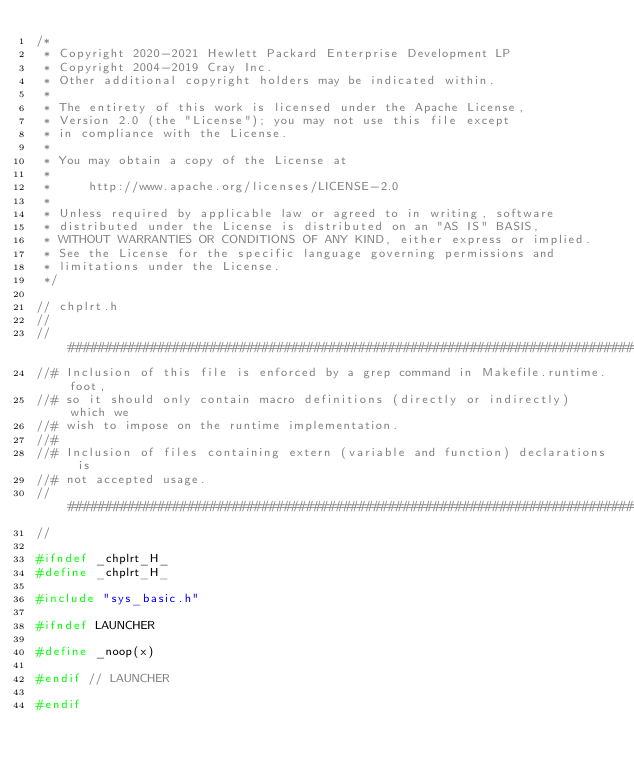<code> <loc_0><loc_0><loc_500><loc_500><_C_>/*
 * Copyright 2020-2021 Hewlett Packard Enterprise Development LP
 * Copyright 2004-2019 Cray Inc.
 * Other additional copyright holders may be indicated within.
 * 
 * The entirety of this work is licensed under the Apache License,
 * Version 2.0 (the "License"); you may not use this file except
 * in compliance with the License.
 * 
 * You may obtain a copy of the License at
 * 
 *     http://www.apache.org/licenses/LICENSE-2.0
 * 
 * Unless required by applicable law or agreed to in writing, software
 * distributed under the License is distributed on an "AS IS" BASIS,
 * WITHOUT WARRANTIES OR CONDITIONS OF ANY KIND, either express or implied.
 * See the License for the specific language governing permissions and
 * limitations under the License.
 */

// chplrt.h
//
//################################################################################
//# Inclusion of this file is enforced by a grep command in Makefile.runtime.foot,
//# so it should only contain macro definitions (directly or indirectly) which we
//# wish to impose on the runtime implementation.
//#
//# Inclusion of files containing extern (variable and function) declarations is
//# not accepted usage.
//################################################################################
//

#ifndef _chplrt_H_
#define _chplrt_H_

#include "sys_basic.h"

#ifndef LAUNCHER

#define _noop(x)

#endif // LAUNCHER

#endif
</code> 